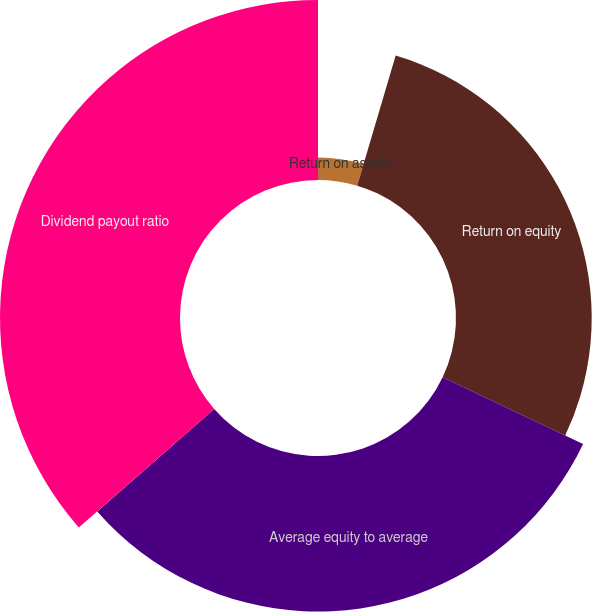Convert chart to OTSL. <chart><loc_0><loc_0><loc_500><loc_500><pie_chart><fcel>Return on assets<fcel>Return on equity<fcel>Average equity to average<fcel>Dividend payout ratio<nl><fcel>4.58%<fcel>27.48%<fcel>31.49%<fcel>36.45%<nl></chart> 